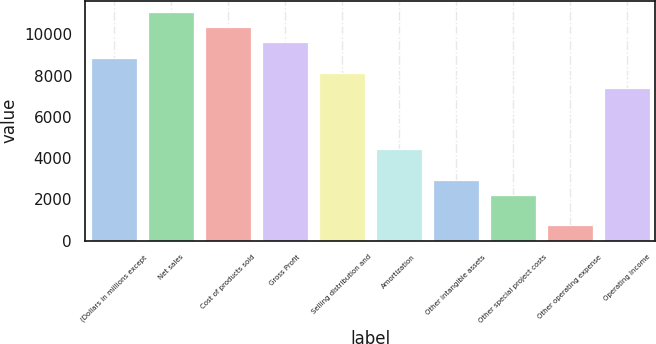Convert chart. <chart><loc_0><loc_0><loc_500><loc_500><bar_chart><fcel>(Dollars in millions except<fcel>Net sales<fcel>Cost of products sold<fcel>Gross Profit<fcel>Selling distribution and<fcel>Amortization<fcel>Other intangible assets<fcel>Other special project costs<fcel>Other operating expense<fcel>Operating Income<nl><fcel>8870.54<fcel>11087.9<fcel>10348.8<fcel>9609.66<fcel>8131.42<fcel>4435.82<fcel>2957.58<fcel>2218.46<fcel>740.22<fcel>7392.3<nl></chart> 